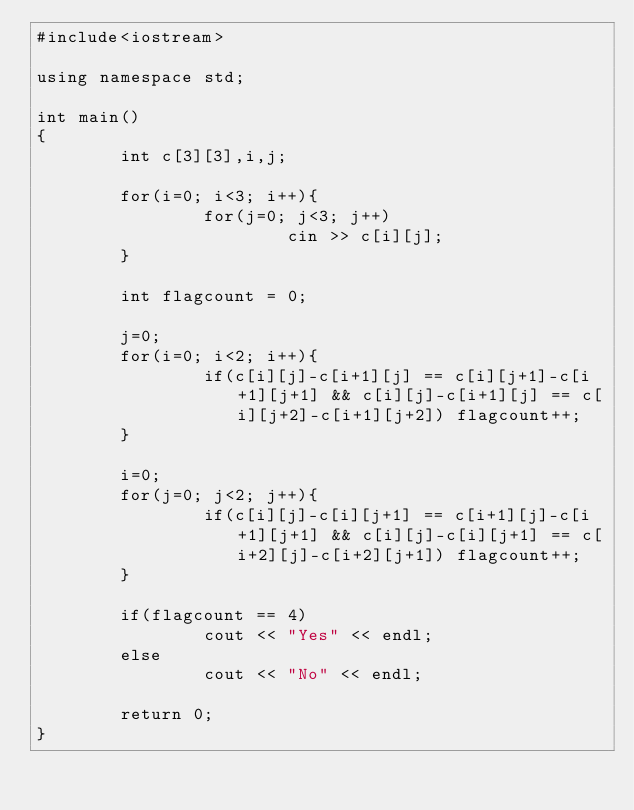<code> <loc_0><loc_0><loc_500><loc_500><_C++_>#include<iostream>

using namespace std;

int main()
{
        int c[3][3],i,j;

        for(i=0; i<3; i++){
                for(j=0; j<3; j++)
                        cin >> c[i][j];
        }

        int flagcount = 0;

        j=0;
        for(i=0; i<2; i++){
                if(c[i][j]-c[i+1][j] == c[i][j+1]-c[i+1][j+1] && c[i][j]-c[i+1][j] == c[i][j+2]-c[i+1][j+2]) flagcount++;
        }

        i=0;
        for(j=0; j<2; j++){
                if(c[i][j]-c[i][j+1] == c[i+1][j]-c[i+1][j+1] && c[i][j]-c[i][j+1] == c[i+2][j]-c[i+2][j+1]) flagcount++;
        }

        if(flagcount == 4)
                cout << "Yes" << endl;
        else
                cout << "No" << endl;

        return 0;
}</code> 